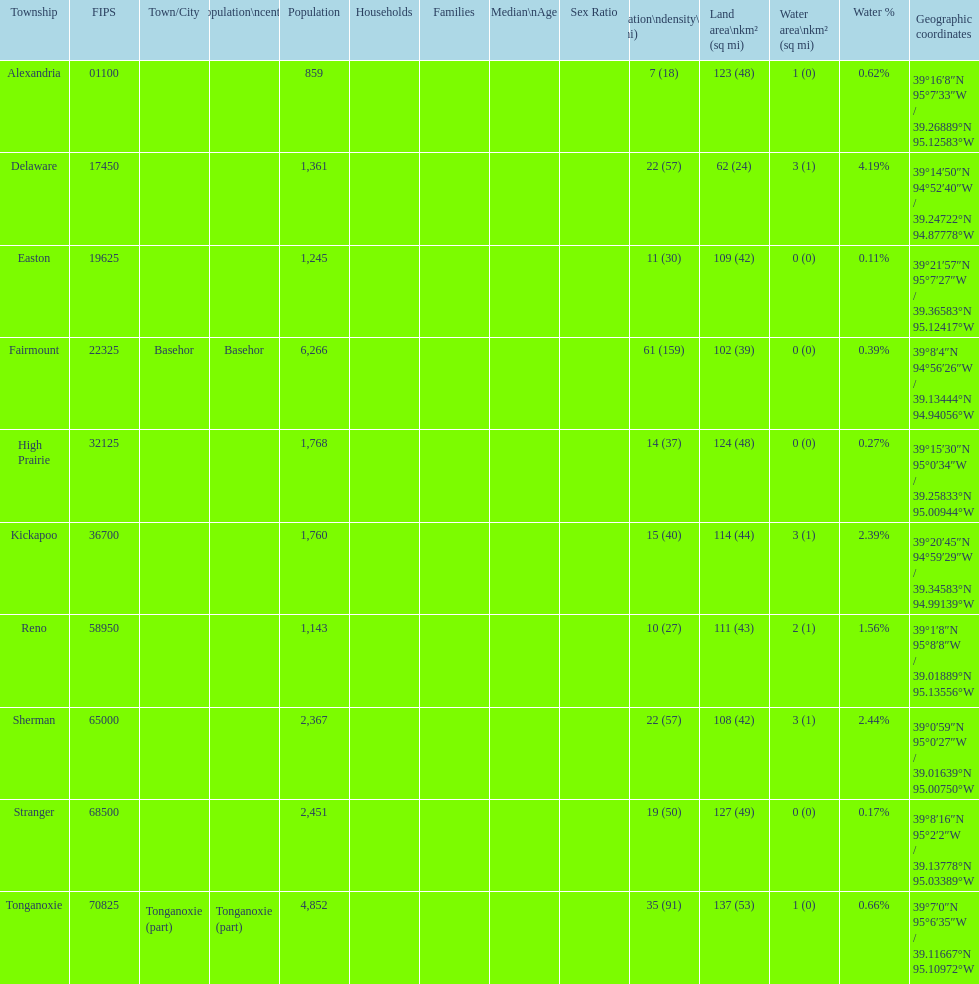What is the number of townships with a population larger than 2,000? 4. 